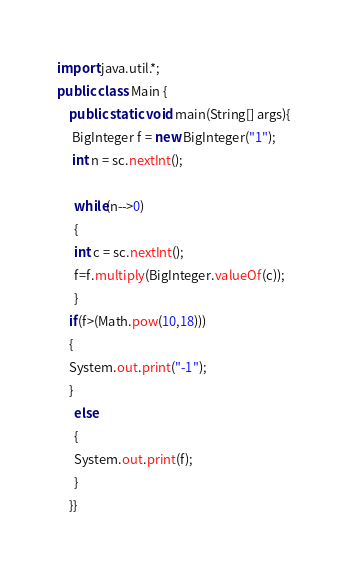<code> <loc_0><loc_0><loc_500><loc_500><_Java_>import java.util.*;
public class Main {
	public static void main(String[] args){ 
     BigInteger f = new BigInteger("1");
     int n = sc.nextInt(); 
      
      while(n-->0) 
      { 
      int c = sc.nextInt();  
      f=f.multiply(BigInteger.valueOf(c));
      } 
    if(f>(Math.pow(10,18))) 
    {
    System.out.print("-1");
    } 
      else 
      {
      System.out.print(f);
      }
    }}</code> 